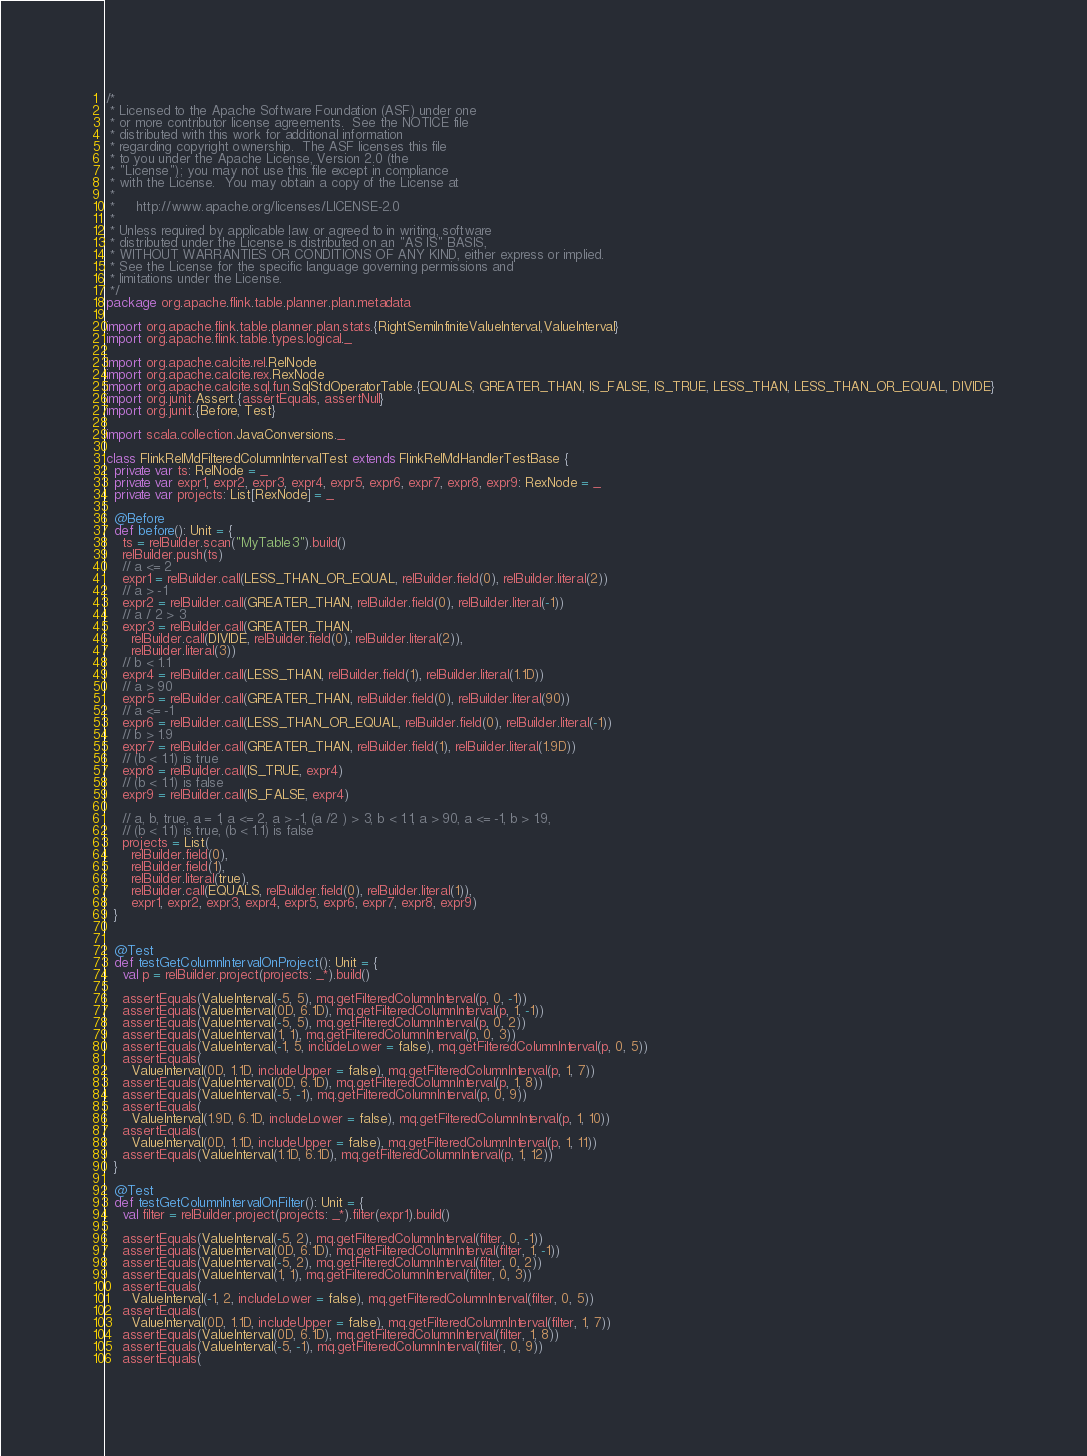<code> <loc_0><loc_0><loc_500><loc_500><_Scala_>/*
 * Licensed to the Apache Software Foundation (ASF) under one
 * or more contributor license agreements.  See the NOTICE file
 * distributed with this work for additional information
 * regarding copyright ownership.  The ASF licenses this file
 * to you under the Apache License, Version 2.0 (the
 * "License"); you may not use this file except in compliance
 * with the License.  You may obtain a copy of the License at
 *
 *     http://www.apache.org/licenses/LICENSE-2.0
 *
 * Unless required by applicable law or agreed to in writing, software
 * distributed under the License is distributed on an "AS IS" BASIS,
 * WITHOUT WARRANTIES OR CONDITIONS OF ANY KIND, either express or implied.
 * See the License for the specific language governing permissions and
 * limitations under the License.
 */
package org.apache.flink.table.planner.plan.metadata

import org.apache.flink.table.planner.plan.stats.{RightSemiInfiniteValueInterval,ValueInterval}
import org.apache.flink.table.types.logical._

import org.apache.calcite.rel.RelNode
import org.apache.calcite.rex.RexNode
import org.apache.calcite.sql.fun.SqlStdOperatorTable.{EQUALS, GREATER_THAN, IS_FALSE, IS_TRUE, LESS_THAN, LESS_THAN_OR_EQUAL, DIVIDE}
import org.junit.Assert.{assertEquals, assertNull}
import org.junit.{Before, Test}

import scala.collection.JavaConversions._

class FlinkRelMdFilteredColumnIntervalTest extends FlinkRelMdHandlerTestBase {
  private var ts: RelNode = _
  private var expr1, expr2, expr3, expr4, expr5, expr6, expr7, expr8, expr9: RexNode = _
  private var projects: List[RexNode] = _

  @Before
  def before(): Unit = {
    ts = relBuilder.scan("MyTable3").build()
    relBuilder.push(ts)
    // a <= 2
    expr1 = relBuilder.call(LESS_THAN_OR_EQUAL, relBuilder.field(0), relBuilder.literal(2))
    // a > -1
    expr2 = relBuilder.call(GREATER_THAN, relBuilder.field(0), relBuilder.literal(-1))
    // a / 2 > 3
    expr3 = relBuilder.call(GREATER_THAN,
      relBuilder.call(DIVIDE, relBuilder.field(0), relBuilder.literal(2)),
      relBuilder.literal(3))
    // b < 1.1
    expr4 = relBuilder.call(LESS_THAN, relBuilder.field(1), relBuilder.literal(1.1D))
    // a > 90
    expr5 = relBuilder.call(GREATER_THAN, relBuilder.field(0), relBuilder.literal(90))
    // a <= -1
    expr6 = relBuilder.call(LESS_THAN_OR_EQUAL, relBuilder.field(0), relBuilder.literal(-1))
    // b > 1.9
    expr7 = relBuilder.call(GREATER_THAN, relBuilder.field(1), relBuilder.literal(1.9D))
    // (b < 1.1) is true
    expr8 = relBuilder.call(IS_TRUE, expr4)
    // (b < 1.1) is false
    expr9 = relBuilder.call(IS_FALSE, expr4)

    // a, b, true, a = 1, a <= 2, a > -1, (a /2 ) > 3, b < 1.1, a > 90, a <= -1, b > 1.9,
    // (b < 1.1) is true, (b < 1.1) is false
    projects = List(
      relBuilder.field(0),
      relBuilder.field(1),
      relBuilder.literal(true),
      relBuilder.call(EQUALS, relBuilder.field(0), relBuilder.literal(1)),
      expr1, expr2, expr3, expr4, expr5, expr6, expr7, expr8, expr9)
  }


  @Test
  def testGetColumnIntervalOnProject(): Unit = {
    val p = relBuilder.project(projects: _*).build()

    assertEquals(ValueInterval(-5, 5), mq.getFilteredColumnInterval(p, 0, -1))
    assertEquals(ValueInterval(0D, 6.1D), mq.getFilteredColumnInterval(p, 1, -1))
    assertEquals(ValueInterval(-5, 5), mq.getFilteredColumnInterval(p, 0, 2))
    assertEquals(ValueInterval(1, 1), mq.getFilteredColumnInterval(p, 0, 3))
    assertEquals(ValueInterval(-1, 5, includeLower = false), mq.getFilteredColumnInterval(p, 0, 5))
    assertEquals(
      ValueInterval(0D, 1.1D, includeUpper = false), mq.getFilteredColumnInterval(p, 1, 7))
    assertEquals(ValueInterval(0D, 6.1D), mq.getFilteredColumnInterval(p, 1, 8))
    assertEquals(ValueInterval(-5, -1), mq.getFilteredColumnInterval(p, 0, 9))
    assertEquals(
      ValueInterval(1.9D, 6.1D, includeLower = false), mq.getFilteredColumnInterval(p, 1, 10))
    assertEquals(
      ValueInterval(0D, 1.1D, includeUpper = false), mq.getFilteredColumnInterval(p, 1, 11))
    assertEquals(ValueInterval(1.1D, 6.1D), mq.getFilteredColumnInterval(p, 1, 12))
  }

  @Test
  def testGetColumnIntervalOnFilter(): Unit = {
    val filter = relBuilder.project(projects: _*).filter(expr1).build()

    assertEquals(ValueInterval(-5, 2), mq.getFilteredColumnInterval(filter, 0, -1))
    assertEquals(ValueInterval(0D, 6.1D), mq.getFilteredColumnInterval(filter, 1, -1))
    assertEquals(ValueInterval(-5, 2), mq.getFilteredColumnInterval(filter, 0, 2))
    assertEquals(ValueInterval(1, 1), mq.getFilteredColumnInterval(filter, 0, 3))
    assertEquals(
      ValueInterval(-1, 2, includeLower = false), mq.getFilteredColumnInterval(filter, 0, 5))
    assertEquals(
      ValueInterval(0D, 1.1D, includeUpper = false), mq.getFilteredColumnInterval(filter, 1, 7))
    assertEquals(ValueInterval(0D, 6.1D), mq.getFilteredColumnInterval(filter, 1, 8))
    assertEquals(ValueInterval(-5, -1), mq.getFilteredColumnInterval(filter, 0, 9))
    assertEquals(</code> 